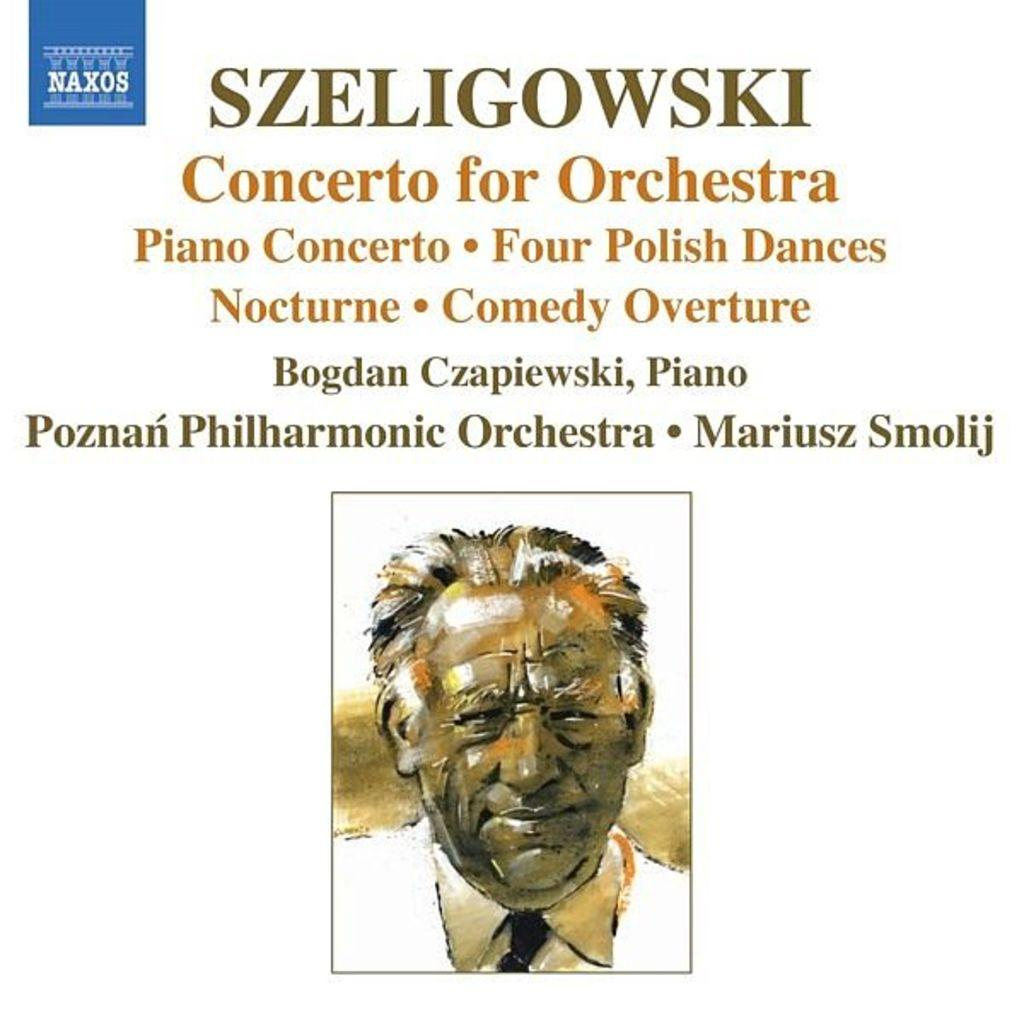What is the main subject of the image? There is a picture of a person in the image. Is there any text associated with the picture of the person? Yes, there is text written above the picture of the person. What amusement park can be seen in the background of the image? There is no amusement park visible in the image; it only features a picture of a person with text above it. 